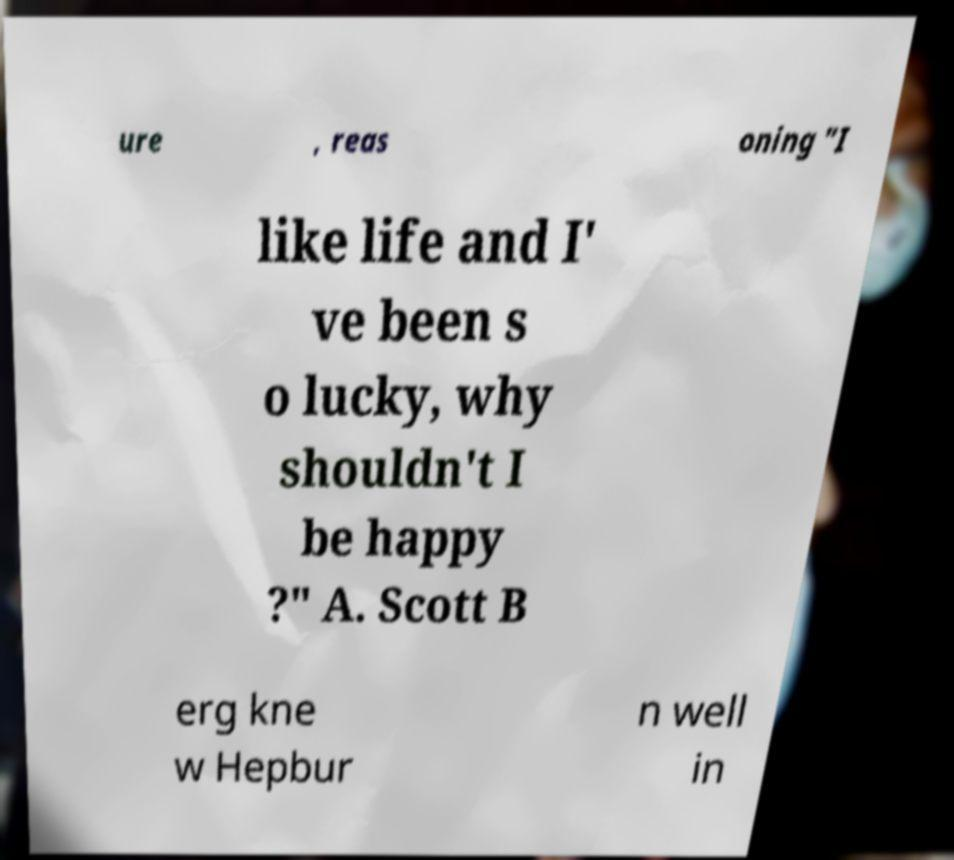For documentation purposes, I need the text within this image transcribed. Could you provide that? ure , reas oning "I like life and I' ve been s o lucky, why shouldn't I be happy ?" A. Scott B erg kne w Hepbur n well in 